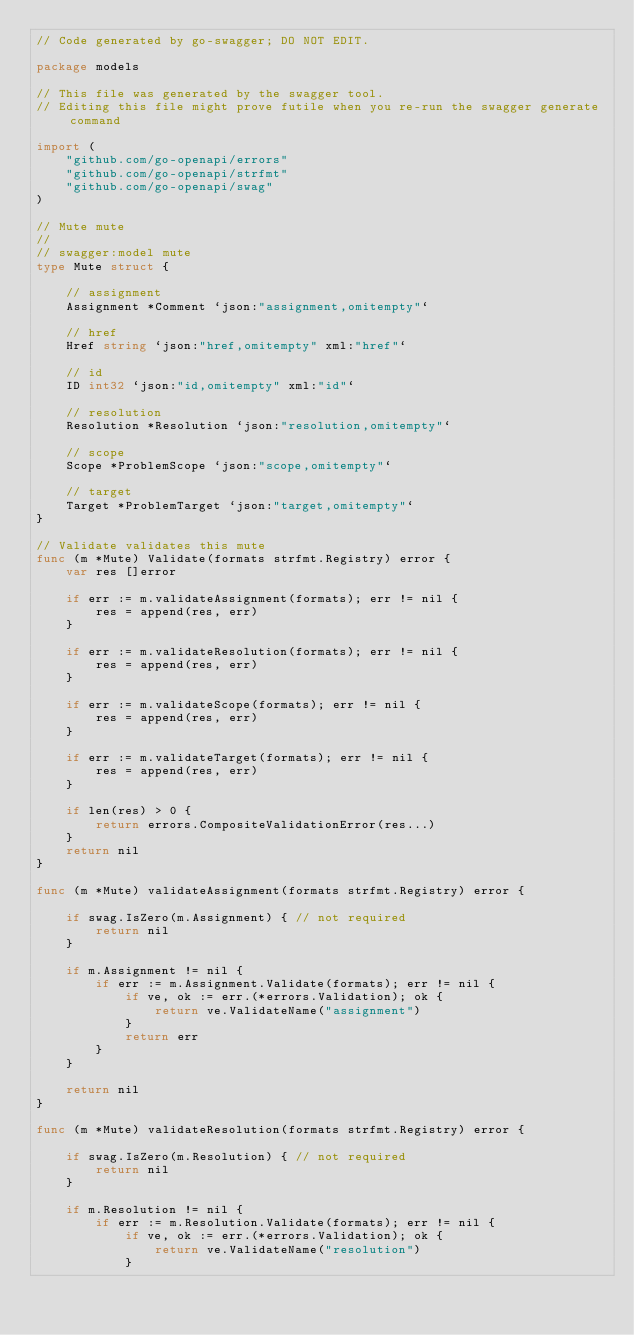<code> <loc_0><loc_0><loc_500><loc_500><_Go_>// Code generated by go-swagger; DO NOT EDIT.

package models

// This file was generated by the swagger tool.
// Editing this file might prove futile when you re-run the swagger generate command

import (
	"github.com/go-openapi/errors"
	"github.com/go-openapi/strfmt"
	"github.com/go-openapi/swag"
)

// Mute mute
//
// swagger:model mute
type Mute struct {

	// assignment
	Assignment *Comment `json:"assignment,omitempty"`

	// href
	Href string `json:"href,omitempty" xml:"href"`

	// id
	ID int32 `json:"id,omitempty" xml:"id"`

	// resolution
	Resolution *Resolution `json:"resolution,omitempty"`

	// scope
	Scope *ProblemScope `json:"scope,omitempty"`

	// target
	Target *ProblemTarget `json:"target,omitempty"`
}

// Validate validates this mute
func (m *Mute) Validate(formats strfmt.Registry) error {
	var res []error

	if err := m.validateAssignment(formats); err != nil {
		res = append(res, err)
	}

	if err := m.validateResolution(formats); err != nil {
		res = append(res, err)
	}

	if err := m.validateScope(formats); err != nil {
		res = append(res, err)
	}

	if err := m.validateTarget(formats); err != nil {
		res = append(res, err)
	}

	if len(res) > 0 {
		return errors.CompositeValidationError(res...)
	}
	return nil
}

func (m *Mute) validateAssignment(formats strfmt.Registry) error {

	if swag.IsZero(m.Assignment) { // not required
		return nil
	}

	if m.Assignment != nil {
		if err := m.Assignment.Validate(formats); err != nil {
			if ve, ok := err.(*errors.Validation); ok {
				return ve.ValidateName("assignment")
			}
			return err
		}
	}

	return nil
}

func (m *Mute) validateResolution(formats strfmt.Registry) error {

	if swag.IsZero(m.Resolution) { // not required
		return nil
	}

	if m.Resolution != nil {
		if err := m.Resolution.Validate(formats); err != nil {
			if ve, ok := err.(*errors.Validation); ok {
				return ve.ValidateName("resolution")
			}</code> 